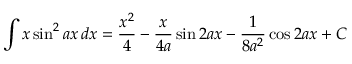Convert formula to latex. <formula><loc_0><loc_0><loc_500><loc_500>\int x \sin ^ { 2 } { a x } \, d x = { \frac { x ^ { 2 } } { 4 } } - { \frac { x } { 4 a } } \sin 2 a x - { \frac { 1 } { 8 a ^ { 2 } } } \cos 2 a x + C</formula> 